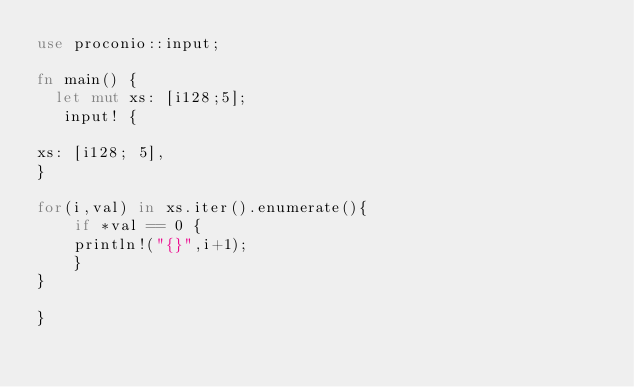<code> <loc_0><loc_0><loc_500><loc_500><_Rust_>use proconio::input;

fn main() {
  let mut xs: [i128;5];
   input! {

xs: [i128; 5],
}

for(i,val) in xs.iter().enumerate(){
    if *val == 0 {
    println!("{}",i+1);
    }
}

}</code> 